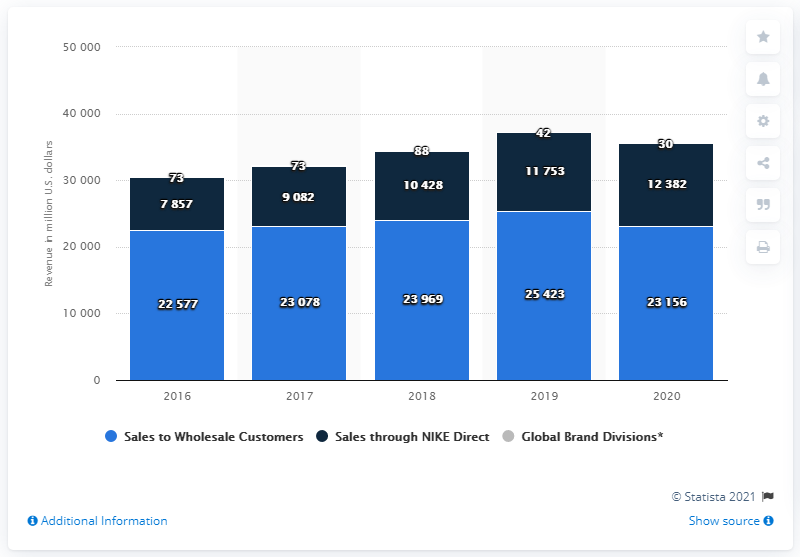List a handful of essential elements in this visual. In 2020, the total sales were 35,538. Nike's revenue from wholesale customers in the United States in 2020 was approximately 23,156 million dollars. 